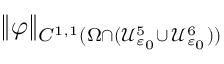<formula> <loc_0><loc_0><loc_500><loc_500>\| \varphi \| _ { C ^ { 1 , 1 } ( \Omega \cap ( \mathcal { U } _ { \varepsilon _ { 0 } } ^ { 5 } \cup \, \mathcal { U } _ { \varepsilon _ { 0 } } ^ { 6 } ) ) }</formula> 